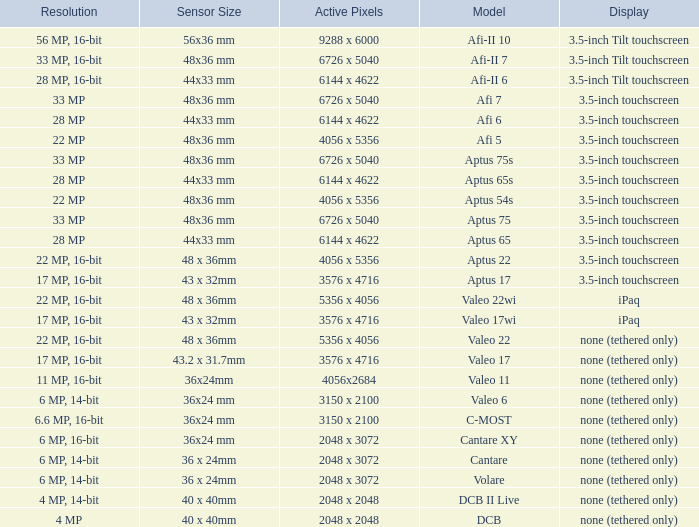What are the active pixels of the c-most model camera? 3150 x 2100. 